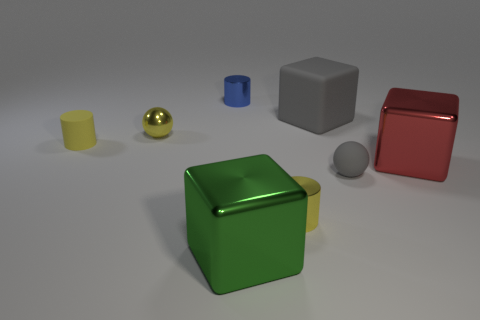Subtract all cyan blocks. Subtract all green balls. How many blocks are left? 3 Add 1 gray metal balls. How many objects exist? 9 Subtract all cylinders. How many objects are left? 5 Subtract 0 red cylinders. How many objects are left? 8 Subtract all green objects. Subtract all yellow metal spheres. How many objects are left? 6 Add 3 yellow cylinders. How many yellow cylinders are left? 5 Add 8 tiny green objects. How many tiny green objects exist? 8 